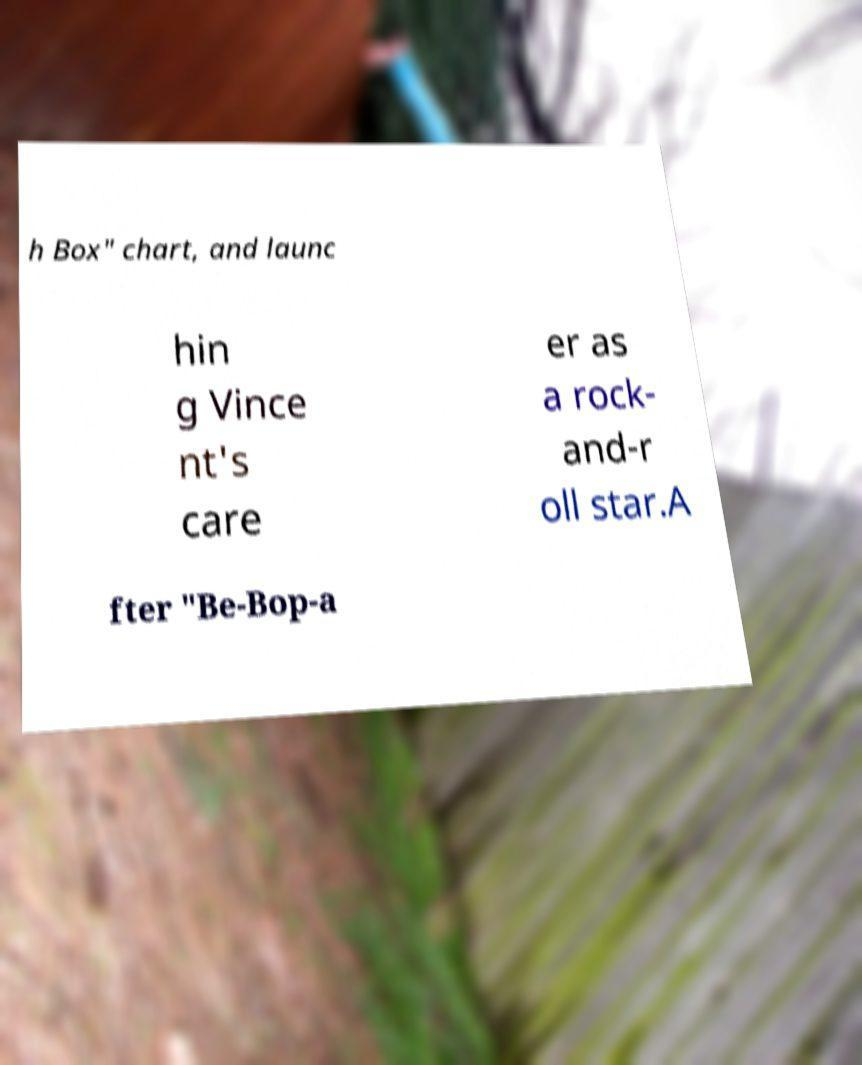What messages or text are displayed in this image? I need them in a readable, typed format. h Box" chart, and launc hin g Vince nt's care er as a rock- and-r oll star.A fter "Be-Bop-a 